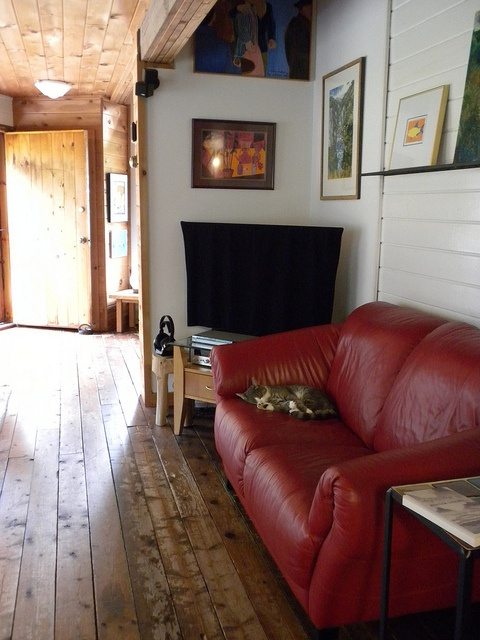Describe the objects in this image and their specific colors. I can see couch in lightgray, maroon, black, and brown tones, tv in lightgray, black, gray, and maroon tones, and cat in lightgray, black, maroon, and gray tones in this image. 